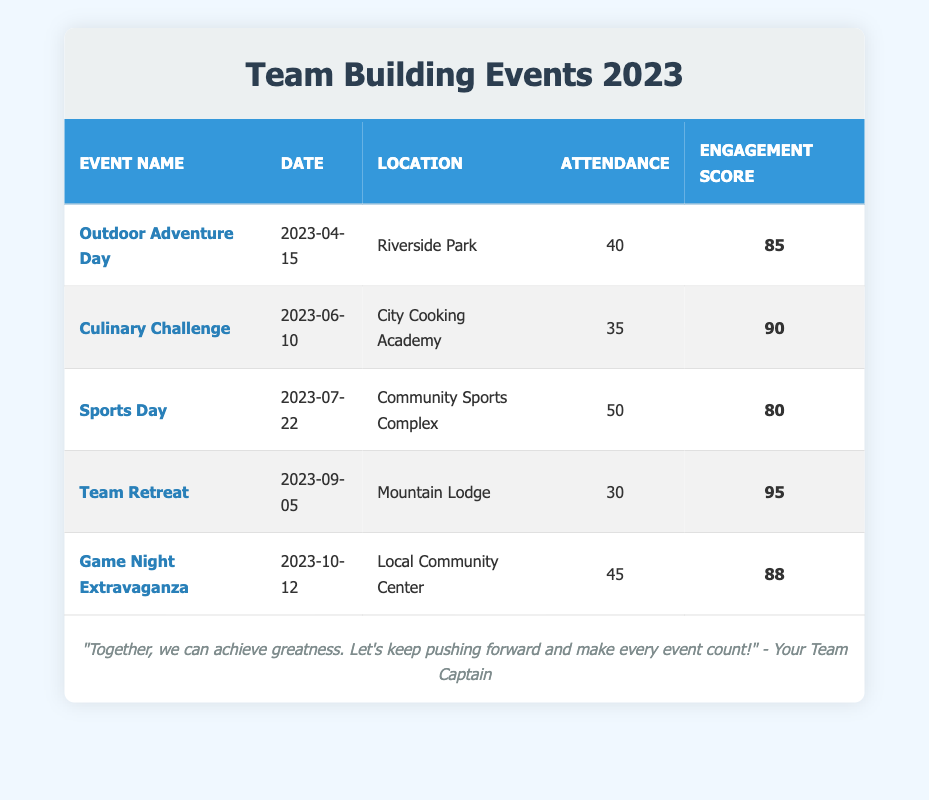What is the location of the "Team Retreat"? The table indicates that the "Team Retreat" event is held at "Mountain Lodge". This can be found in the row that lists the "Team Retreat" event under the "Location" column.
Answer: Mountain Lodge How many people attended the "Culinary Challenge"? The attendance for the "Culinary Challenge" can be found directly in its respective row under the "Attendance" column. It shows that 35 people attended this event.
Answer: 35 What is the engagement score for "Game Night Extravaganza"? The score can be retrieved from the "Game Night Extravaganza" row in the "Engagement Score" column. It shows an engagement score of 88.
Answer: 88 Which event had the highest engagement score? Looking through each event, "Team Retreat" has the highest engagement score listed at 95, which is the maximum value in the Engagement Score column.
Answer: Team Retreat What is the average attendance across all events? To find the average, we first sum up the attendances: 40 + 35 + 50 + 30 + 45 = 200. There are 5 events, so we divide 200 by 5, which gives us an average attendance of 40.
Answer: 40 Is the engagement score for "Outdoor Adventure Day" greater than the score for "Sports Day"? The engagement score for "Outdoor Adventure Day" is 85 and for "Sports Day" it is 80. Since 85 is greater than 80, the statement is true.
Answer: Yes Which event had the lowest attendance? By analyzing the Attendance column: Outdoor Adventure Day (40), Culinary Challenge (35), Sports Day (50), Team Retreat (30), and Game Night Extravaganza (45), "Team Retreat" had the lowest attendance at 30.
Answer: Team Retreat Was the "Culinary Challenge" more engaging than the "Sports Day"? The engagement score for the "Culinary Challenge" is 90, while for "Sports Day" it is 80. Since 90 is greater than 80, the "Culinary Challenge" was indeed more engaging.
Answer: Yes What is the difference in attendance between the "Outdoor Adventure Day" and "Team Retreat"? The attendance for "Outdoor Adventure Day" is 40 and for "Team Retreat" is 30. To find the difference, we subtract: 40 - 30 = 10. So, there is a difference of 10 in attendance.
Answer: 10 